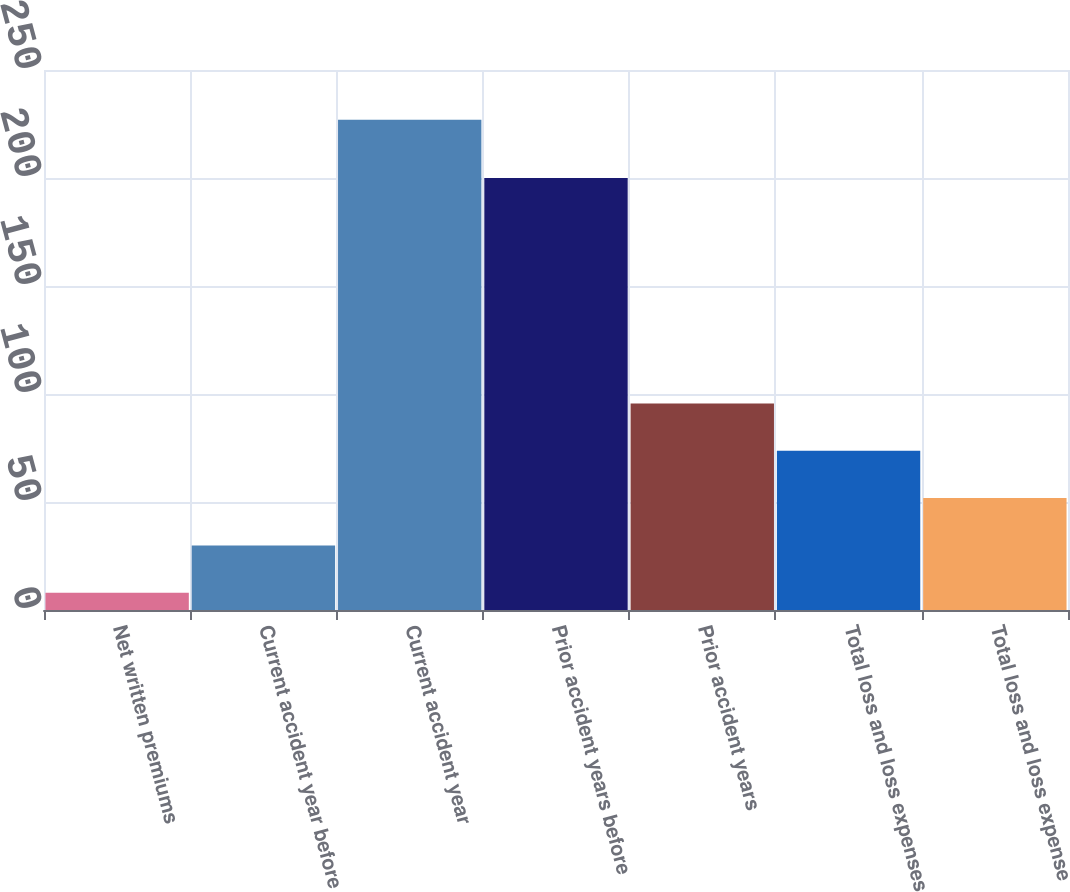Convert chart. <chart><loc_0><loc_0><loc_500><loc_500><bar_chart><fcel>Net written premiums<fcel>Current accident year before<fcel>Current accident year<fcel>Prior accident years before<fcel>Prior accident years<fcel>Total loss and loss expenses<fcel>Total loss and loss expense<nl><fcel>8<fcel>29.9<fcel>227<fcel>200<fcel>95.6<fcel>73.7<fcel>51.8<nl></chart> 